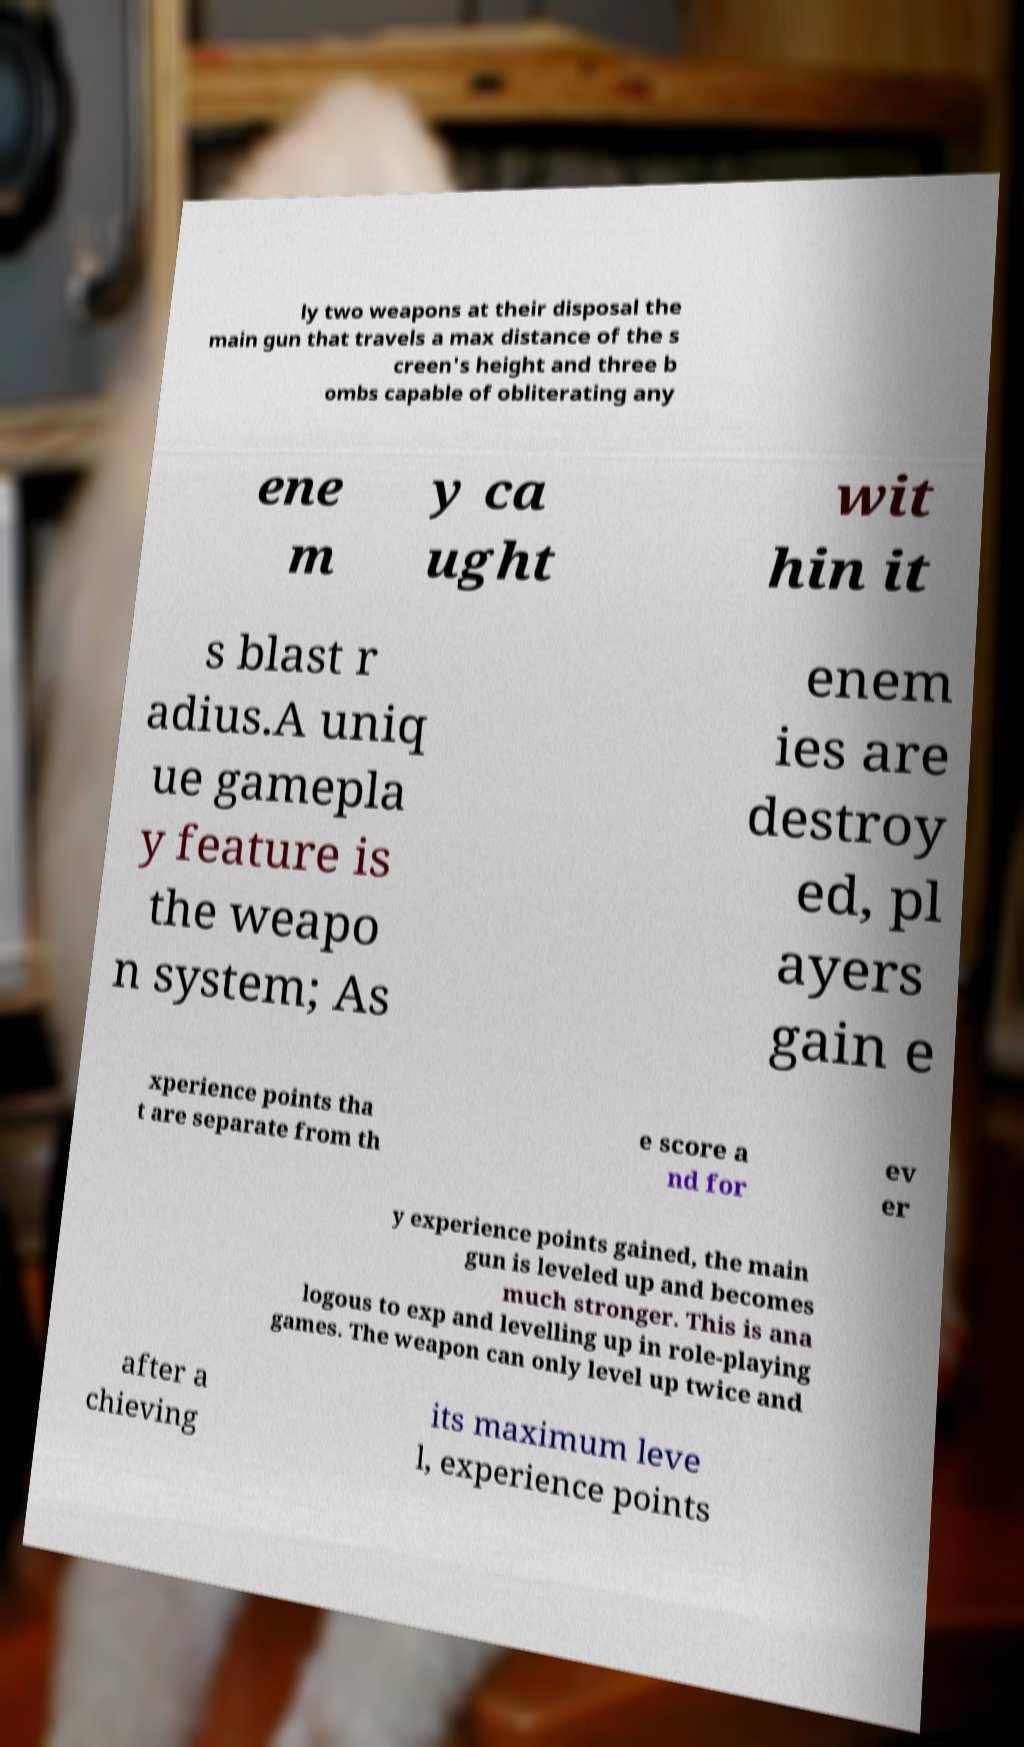For documentation purposes, I need the text within this image transcribed. Could you provide that? ly two weapons at their disposal the main gun that travels a max distance of the s creen's height and three b ombs capable of obliterating any ene m y ca ught wit hin it s blast r adius.A uniq ue gamepla y feature is the weapo n system; As enem ies are destroy ed, pl ayers gain e xperience points tha t are separate from th e score a nd for ev er y experience points gained, the main gun is leveled up and becomes much stronger. This is ana logous to exp and levelling up in role-playing games. The weapon can only level up twice and after a chieving its maximum leve l, experience points 